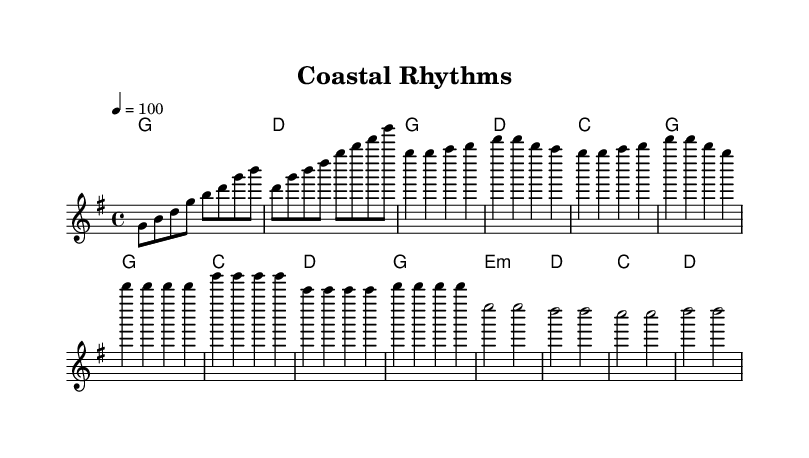What is the key signature of this music? The key signature indicates the presence of one sharp, which corresponds to the G major scale. Therefore, the piece is in G major.
Answer: G major What is the time signature of this music? The time signature is found at the beginning of the score, showing four beats per measure, indicating a 4/4 meter.
Answer: 4/4 What is the tempo marking for this piece? The tempo marking is located at the beginning of the score where it states "4 = 100", indicating a quarter note should be played at a speed of 100 beats per minute.
Answer: 100 How many measures are in the chorus section? The chorus section includes four measures, which can be counted from the musical notation provided in that part of the score.
Answer: 4 What type of chord is used in the bridge section? The bridge section features an E minor chord indicated by the "e:m" notation, which distinguishes it from the other major chords in the score.
Answer: E minor Which chord is used most frequently throughout the piece? By analyzing the harmonies listed, it is clear that the G major chord appears in each main section of the piece, making it the most recurring chord.
Answer: G major What is a characteristic of Rhythm and Blues reflected in this music? The use of a call-and-response structure is typical of Rhythm and Blues, evident in the flowing melody verses that interact with the harmonies, showcasing the blend of traditional and modern sounds.
Answer: Call-and-response 